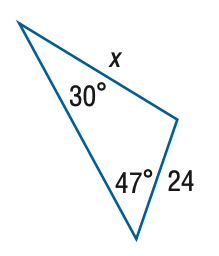Question: Find x. Round side measure to the nearest tenth.
Choices:
A. 16.4
B. 18.0
C. 32.0
D. 35.1
Answer with the letter. Answer: D 